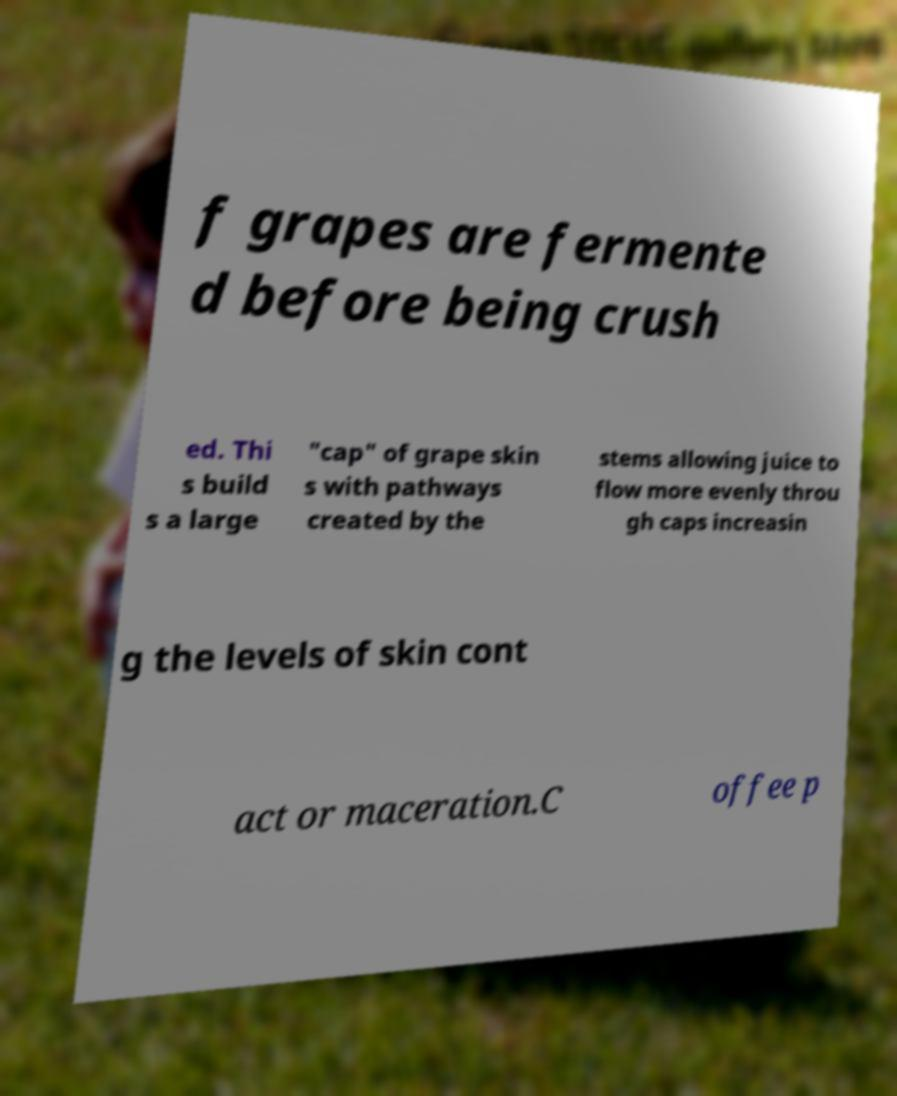For documentation purposes, I need the text within this image transcribed. Could you provide that? f grapes are fermente d before being crush ed. Thi s build s a large "cap" of grape skin s with pathways created by the stems allowing juice to flow more evenly throu gh caps increasin g the levels of skin cont act or maceration.C offee p 